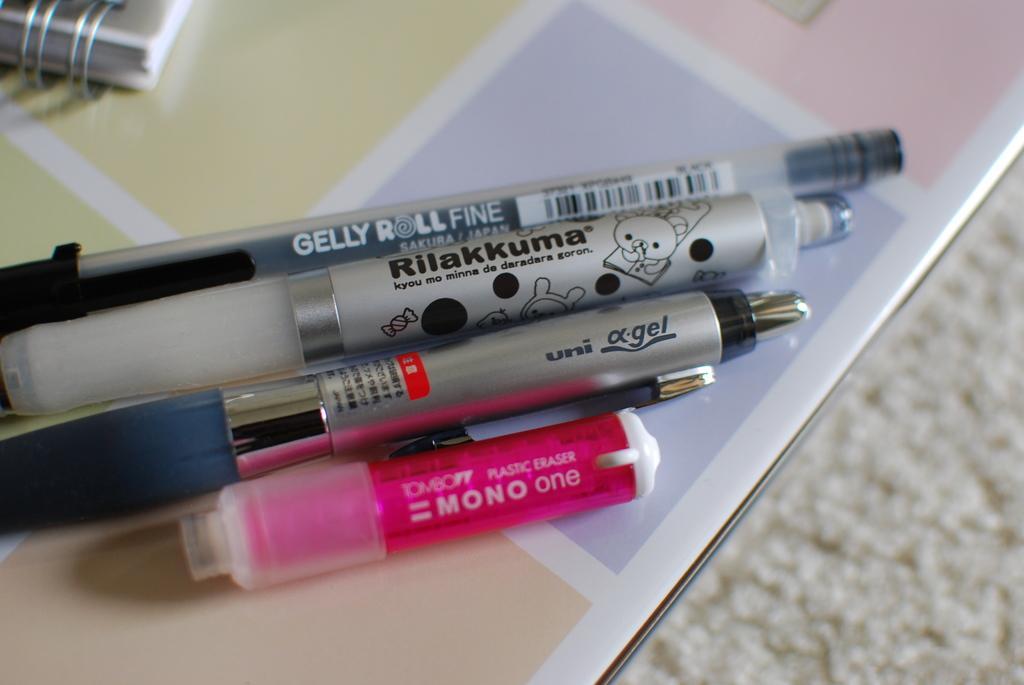Can you describe this image briefly? In this image we can see one book, some pens, one pink object and one small white object on the table. There is one white object on the floor looks like a carpet. 